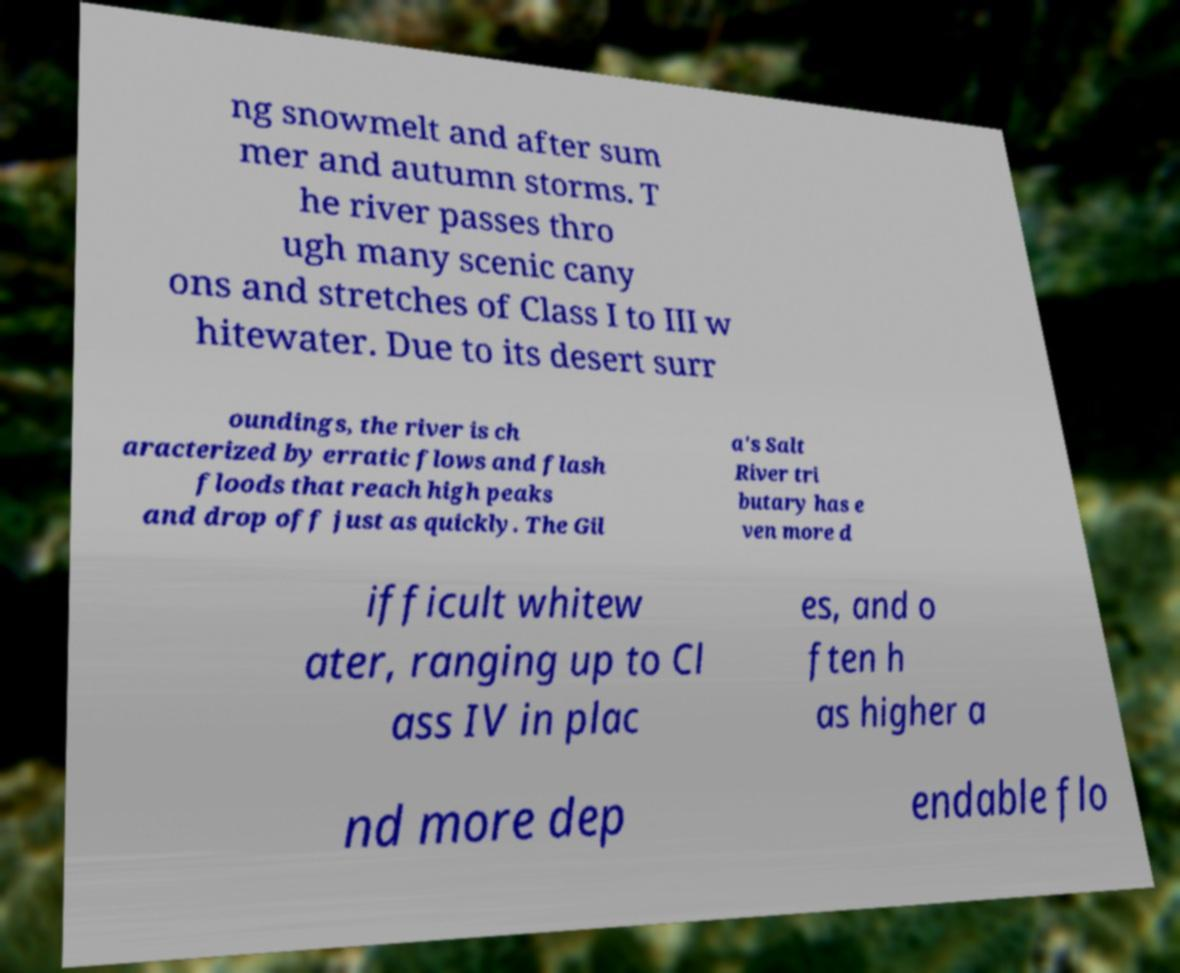Could you extract and type out the text from this image? ng snowmelt and after sum mer and autumn storms. T he river passes thro ugh many scenic cany ons and stretches of Class I to III w hitewater. Due to its desert surr oundings, the river is ch aracterized by erratic flows and flash floods that reach high peaks and drop off just as quickly. The Gil a's Salt River tri butary has e ven more d ifficult whitew ater, ranging up to Cl ass IV in plac es, and o ften h as higher a nd more dep endable flo 